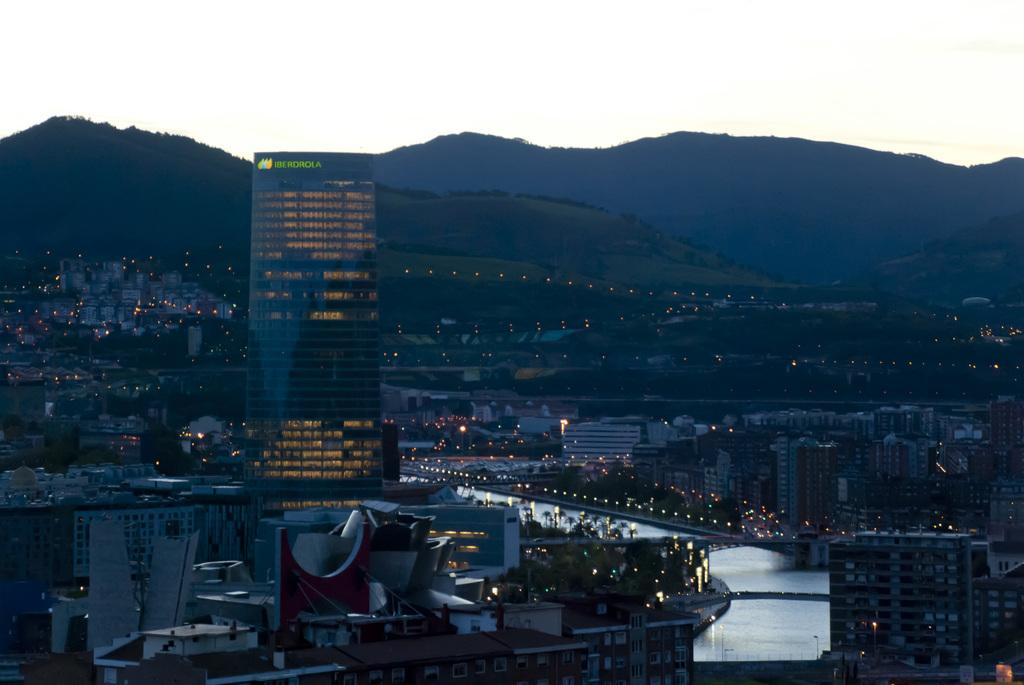What type of structures can be seen in the image? There are buildings in the image. What else is visible in the image besides the buildings? There are lights and water visible in the image. What can be seen in the background of the image? There are mountains and the sky visible in the background of the image. Where is the loaf of bread located in the image? There is no loaf of bread present in the image. What type of fruit can be seen hanging from the mountains in the image? There are no fruits hanging from the mountains in the image; the mountains are in the background and do not have any visible fruits. 